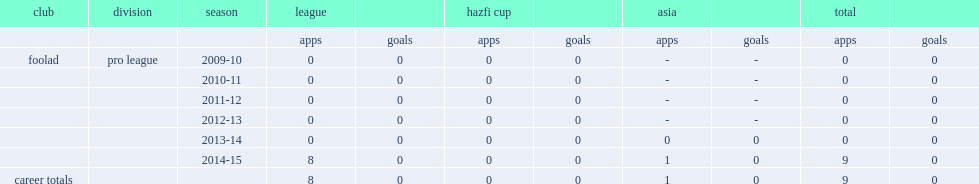Which club did ali sina rabbani make debut in 2014-15 pro league? Foolad. Would you mind parsing the complete table? {'header': ['club', 'division', 'season', 'league', '', 'hazfi cup', '', 'asia', '', 'total', ''], 'rows': [['', '', '', 'apps', 'goals', 'apps', 'goals', 'apps', 'goals', 'apps', 'goals'], ['foolad', 'pro league', '2009-10', '0', '0', '0', '0', '-', '-', '0', '0'], ['', '', '2010-11', '0', '0', '0', '0', '-', '-', '0', '0'], ['', '', '2011-12', '0', '0', '0', '0', '-', '-', '0', '0'], ['', '', '2012-13', '0', '0', '0', '0', '-', '-', '0', '0'], ['', '', '2013-14', '0', '0', '0', '0', '0', '0', '0', '0'], ['', '', '2014-15', '8', '0', '0', '0', '1', '0', '9', '0'], ['career totals', '', '', '8', '0', '0', '0', '1', '0', '9', '0']]} 